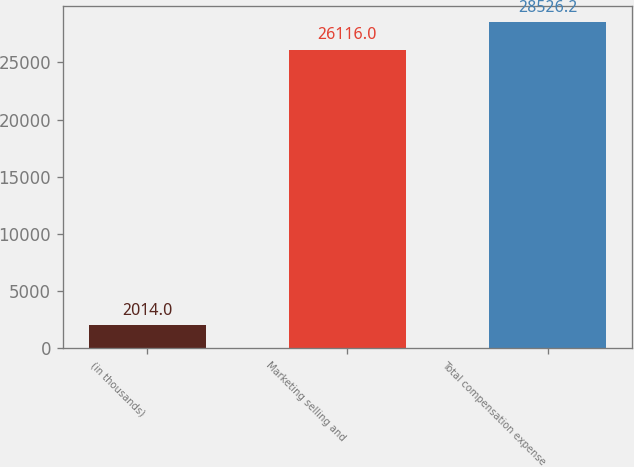<chart> <loc_0><loc_0><loc_500><loc_500><bar_chart><fcel>(in thousands)<fcel>Marketing selling and<fcel>Total compensation expense<nl><fcel>2014<fcel>26116<fcel>28526.2<nl></chart> 